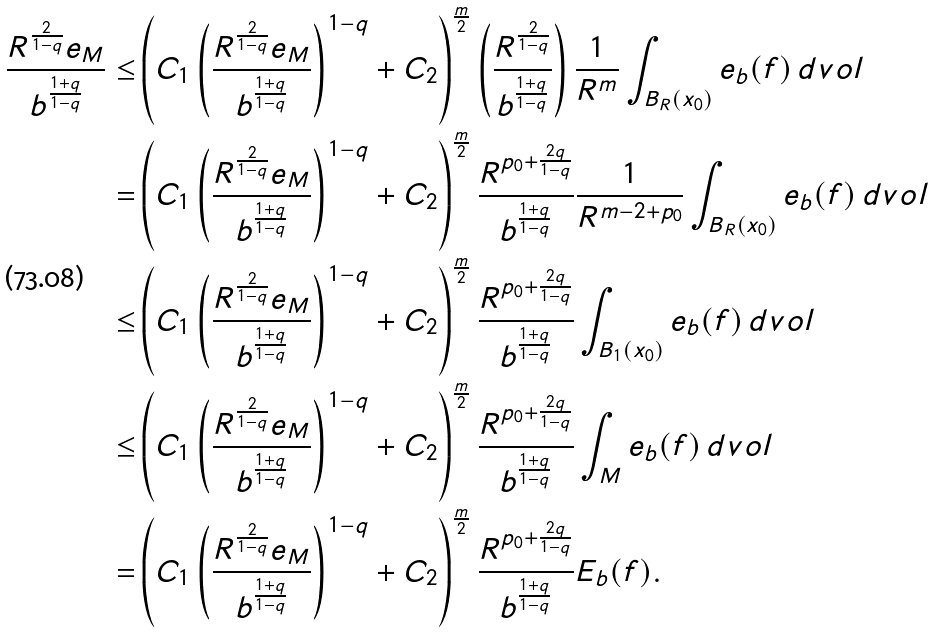<formula> <loc_0><loc_0><loc_500><loc_500>\frac { R ^ { \frac { 2 } { 1 - q } } e _ { M } } { b ^ { \frac { 1 + q } { 1 - q } } } \leq & \left ( C _ { 1 } \left ( \frac { R ^ { \frac { 2 } { 1 - q } } e _ { M } } { b ^ { \frac { 1 + q } { 1 - q } } } \right ) ^ { 1 - q } + C _ { 2 } \right ) ^ { \frac { m } { 2 } } \left ( \frac { R ^ { \frac { 2 } { 1 - q } } } { b ^ { \frac { 1 + q } { 1 - q } } } \right ) \frac { 1 } { R ^ { m } } \int _ { B _ { R } ( x _ { 0 } ) } e _ { b } ( f ) \, d v o l \\ = & \left ( C _ { 1 } \left ( \frac { R ^ { \frac { 2 } { 1 - q } } e _ { M } } { b ^ { \frac { 1 + q } { 1 - q } } } \right ) ^ { 1 - q } + C _ { 2 } \right ) ^ { \frac { m } { 2 } } \frac { R ^ { p _ { 0 } + \frac { 2 q } { 1 - q } } } { b ^ { \frac { 1 + q } { 1 - q } } } \frac { 1 } { R ^ { m - 2 + p _ { 0 } } } \int _ { B _ { R } ( x _ { 0 } ) } e _ { b } ( f ) \, d v o l \\ \leq & \left ( C _ { 1 } \left ( \frac { R ^ { \frac { 2 } { 1 - q } } e _ { M } } { b ^ { \frac { 1 + q } { 1 - q } } } \right ) ^ { 1 - q } + C _ { 2 } \right ) ^ { \frac { m } { 2 } } \frac { R ^ { p _ { 0 } + \frac { 2 q } { 1 - q } } } { b ^ { \frac { 1 + q } { 1 - q } } } \int _ { B _ { 1 } ( x _ { 0 } ) } e _ { b } ( f ) \, d v o l \\ \leq & \left ( C _ { 1 } \left ( \frac { R ^ { \frac { 2 } { 1 - q } } e _ { M } } { b ^ { \frac { 1 + q } { 1 - q } } } \right ) ^ { 1 - q } + C _ { 2 } \right ) ^ { \frac { m } { 2 } } \frac { R ^ { p _ { 0 } + \frac { 2 q } { 1 - q } } } { b ^ { \frac { 1 + q } { 1 - q } } } \int _ { M } e _ { b } ( f ) \, d v o l \\ = & \left ( C _ { 1 } \left ( \frac { R ^ { \frac { 2 } { 1 - q } } e _ { M } } { b ^ { \frac { 1 + q } { 1 - q } } } \right ) ^ { 1 - q } + C _ { 2 } \right ) ^ { \frac { m } { 2 } } \frac { R ^ { p _ { 0 } + \frac { 2 q } { 1 - q } } } { b ^ { \frac { 1 + q } { 1 - q } } } E _ { b } ( f ) .</formula> 